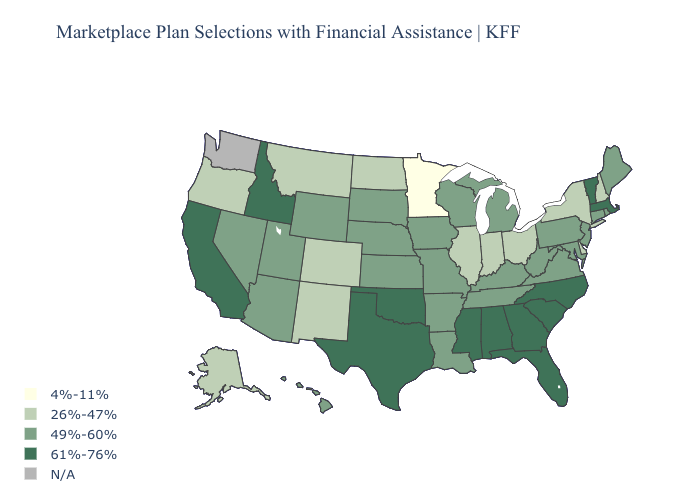Name the states that have a value in the range 49%-60%?
Quick response, please. Arizona, Arkansas, Connecticut, Hawaii, Iowa, Kansas, Kentucky, Louisiana, Maine, Maryland, Michigan, Missouri, Nebraska, Nevada, New Jersey, Pennsylvania, Rhode Island, South Dakota, Tennessee, Utah, Virginia, West Virginia, Wisconsin, Wyoming. Name the states that have a value in the range 49%-60%?
Be succinct. Arizona, Arkansas, Connecticut, Hawaii, Iowa, Kansas, Kentucky, Louisiana, Maine, Maryland, Michigan, Missouri, Nebraska, Nevada, New Jersey, Pennsylvania, Rhode Island, South Dakota, Tennessee, Utah, Virginia, West Virginia, Wisconsin, Wyoming. Does Maine have the highest value in the USA?
Short answer required. No. Name the states that have a value in the range 61%-76%?
Short answer required. Alabama, California, Florida, Georgia, Idaho, Massachusetts, Mississippi, North Carolina, Oklahoma, South Carolina, Texas, Vermont. What is the value of Kentucky?
Be succinct. 49%-60%. What is the lowest value in states that border South Carolina?
Keep it brief. 61%-76%. What is the highest value in states that border Arkansas?
Answer briefly. 61%-76%. Name the states that have a value in the range 26%-47%?
Keep it brief. Alaska, Colorado, Delaware, Illinois, Indiana, Montana, New Hampshire, New Mexico, New York, North Dakota, Ohio, Oregon. Does Utah have the highest value in the West?
Concise answer only. No. Among the states that border Arkansas , does Louisiana have the lowest value?
Write a very short answer. Yes. What is the value of California?
Keep it brief. 61%-76%. Among the states that border New Mexico , which have the lowest value?
Quick response, please. Colorado. What is the value of Delaware?
Quick response, please. 26%-47%. What is the lowest value in the West?
Short answer required. 26%-47%. 